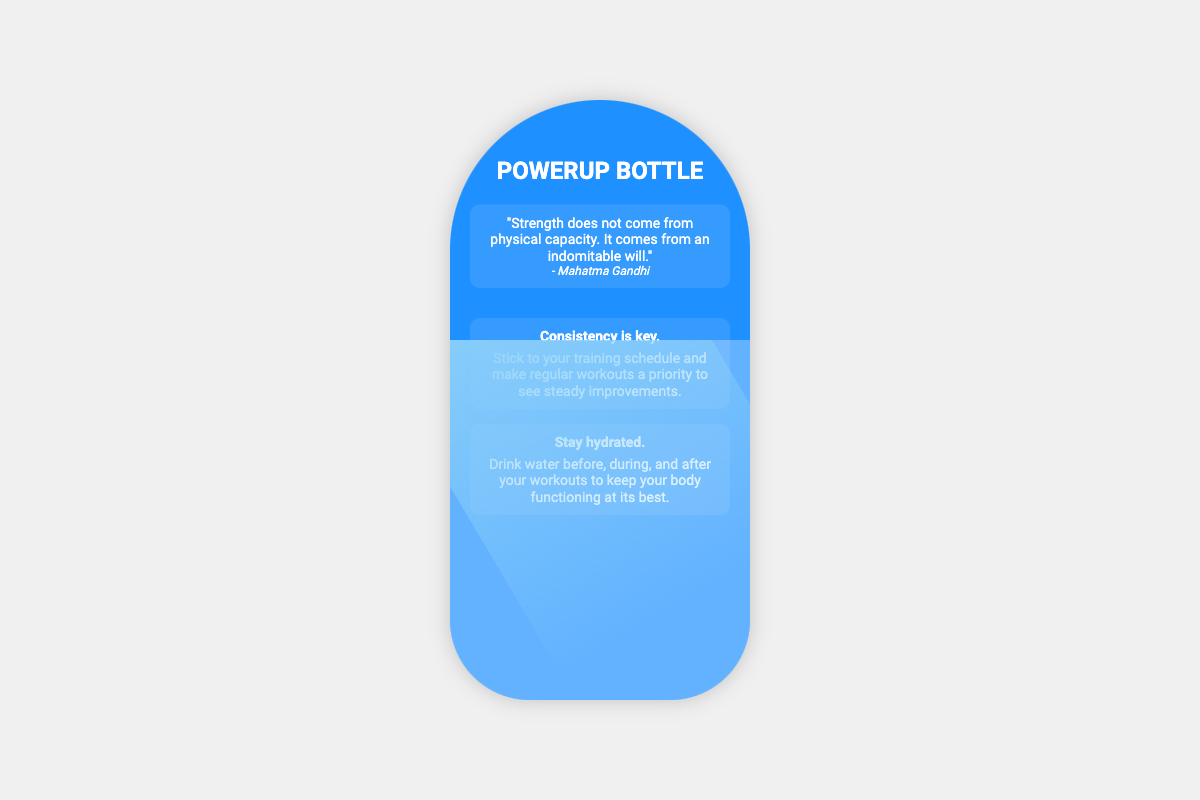What is the name of the product? The product is referred to as the "PowerUp Bottle" in the title section of the document.
Answer: PowerUp Bottle Who is quoted on the bottle? The quote provided is attributed to Mahatma Gandhi, mentioned in the quote section.
Answer: Mahatma Gandhi What does the first quote emphasize? The first quote highlights that strength comes from an indomitable will, according to the text.
Answer: Indomitable will How many training tips are provided? There are two training tips listed in the tips section of the document.
Answer: Two What is the first tip about? The first tip emphasizes the importance of consistency in training schedules for improvements.
Answer: Consistency is key What is suggested to maintain hydration? The document advises drinking water before, during, and after workouts to stay hydrated.
Answer: Stay hydrated What design element is used for the water level? The water level section features a water animation designed to look like moving water.
Answer: Water animation What is the main color theme of the bottle? The primary color of the bottle design is blue, specifically a shade called "dodger blue."
Answer: Dodger blue 